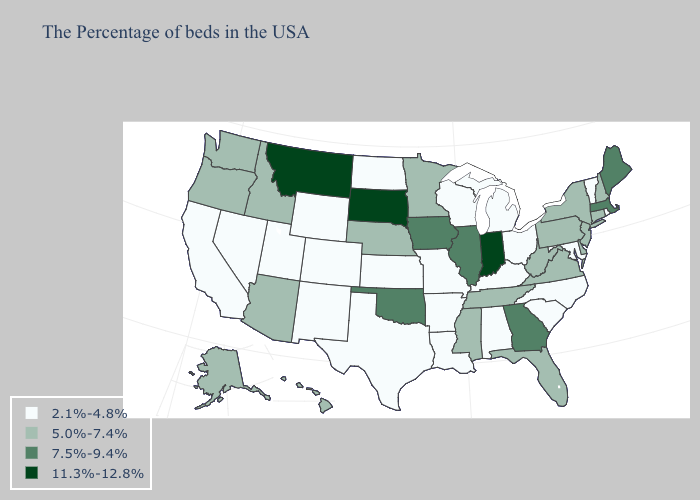Is the legend a continuous bar?
Answer briefly. No. Name the states that have a value in the range 7.5%-9.4%?
Be succinct. Maine, Massachusetts, Georgia, Illinois, Iowa, Oklahoma. What is the highest value in the South ?
Quick response, please. 7.5%-9.4%. What is the value of Wyoming?
Give a very brief answer. 2.1%-4.8%. Among the states that border Oregon , which have the lowest value?
Concise answer only. Nevada, California. Which states have the lowest value in the West?
Answer briefly. Wyoming, Colorado, New Mexico, Utah, Nevada, California. Is the legend a continuous bar?
Concise answer only. No. Does Alaska have a lower value than Iowa?
Concise answer only. Yes. What is the lowest value in the South?
Quick response, please. 2.1%-4.8%. Among the states that border Florida , which have the highest value?
Concise answer only. Georgia. What is the highest value in the MidWest ?
Write a very short answer. 11.3%-12.8%. Does Montana have the same value as Washington?
Quick response, please. No. Which states have the lowest value in the USA?
Quick response, please. Rhode Island, Vermont, Maryland, North Carolina, South Carolina, Ohio, Michigan, Kentucky, Alabama, Wisconsin, Louisiana, Missouri, Arkansas, Kansas, Texas, North Dakota, Wyoming, Colorado, New Mexico, Utah, Nevada, California. Does Rhode Island have the highest value in the Northeast?
Answer briefly. No. Does New Hampshire have the highest value in the Northeast?
Give a very brief answer. No. 